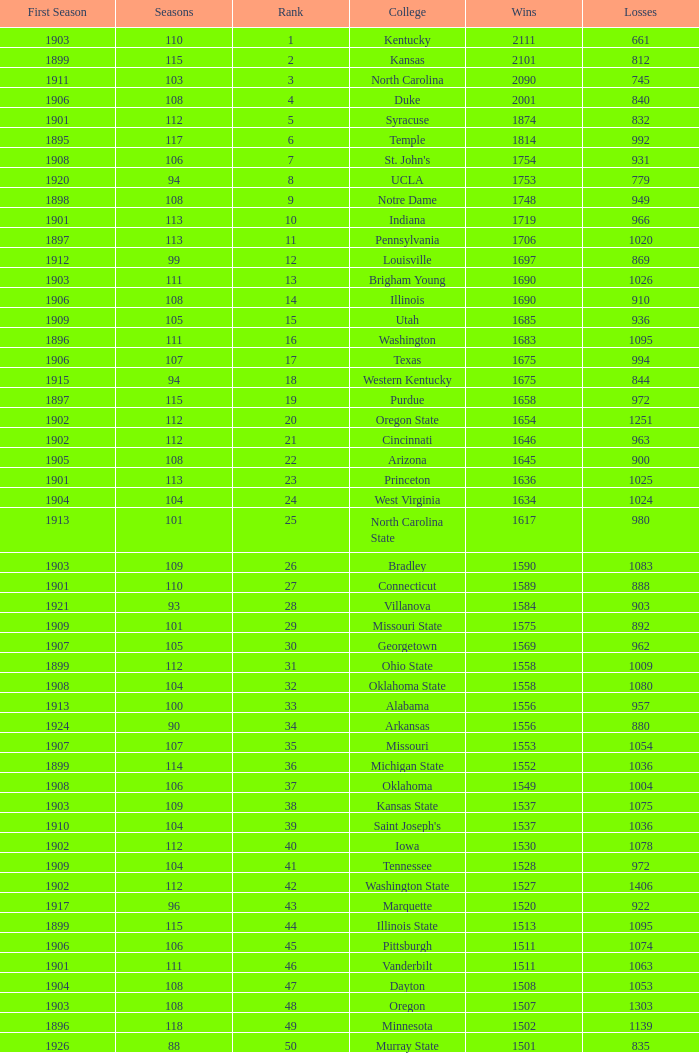What is the total of First Season games with 1537 Wins and a Season greater than 109? None. 